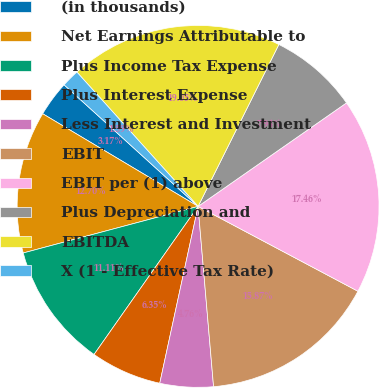Convert chart. <chart><loc_0><loc_0><loc_500><loc_500><pie_chart><fcel>(in thousands)<fcel>Net Earnings Attributable to<fcel>Plus Income Tax Expense<fcel>Plus Interest Expense<fcel>Less Interest and Investment<fcel>EBIT<fcel>EBIT per (1) above<fcel>Plus Depreciation and<fcel>EBITDA<fcel>X (1 - Effective Tax Rate)<nl><fcel>3.17%<fcel>12.7%<fcel>11.11%<fcel>6.35%<fcel>4.76%<fcel>15.87%<fcel>17.46%<fcel>7.94%<fcel>19.05%<fcel>1.59%<nl></chart> 